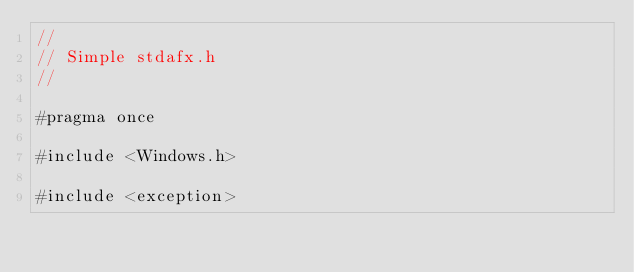Convert code to text. <code><loc_0><loc_0><loc_500><loc_500><_C_>//
// Simple stdafx.h
//

#pragma once

#include <Windows.h>

#include <exception>
</code> 